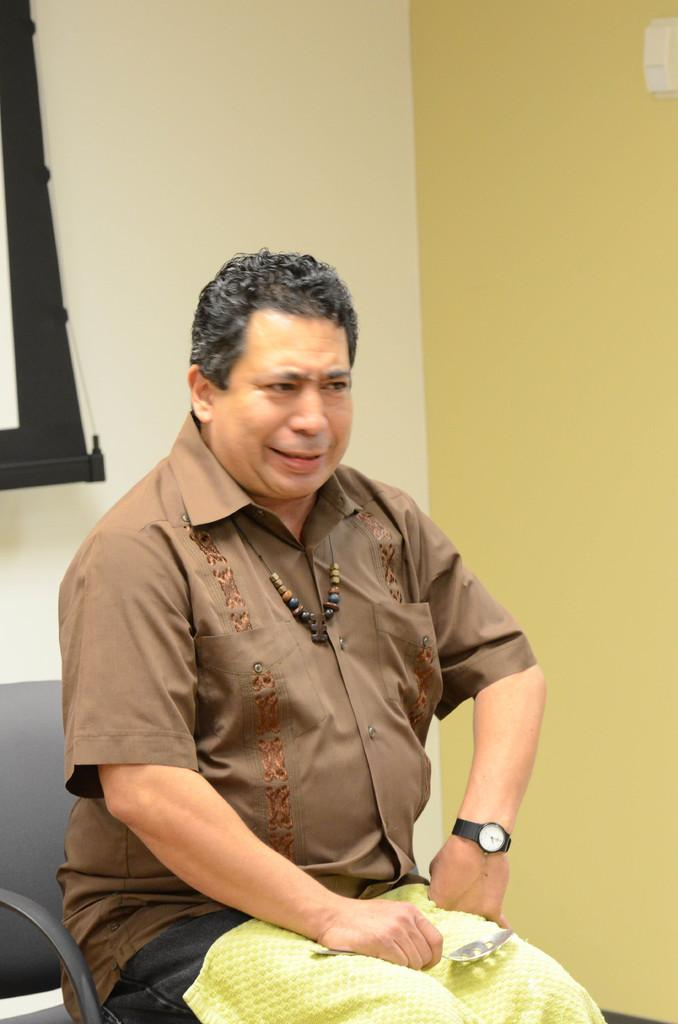Who or what is the main subject in the image? There is a person in the image. What is the person doing in the image? The person is sitting on a chair. What can be seen behind the person in the image? There is a wall in the background of the image. What type of glass is the person holding in the image? There is no glass present in the image; the person is sitting on a chair with a wall in the background. 